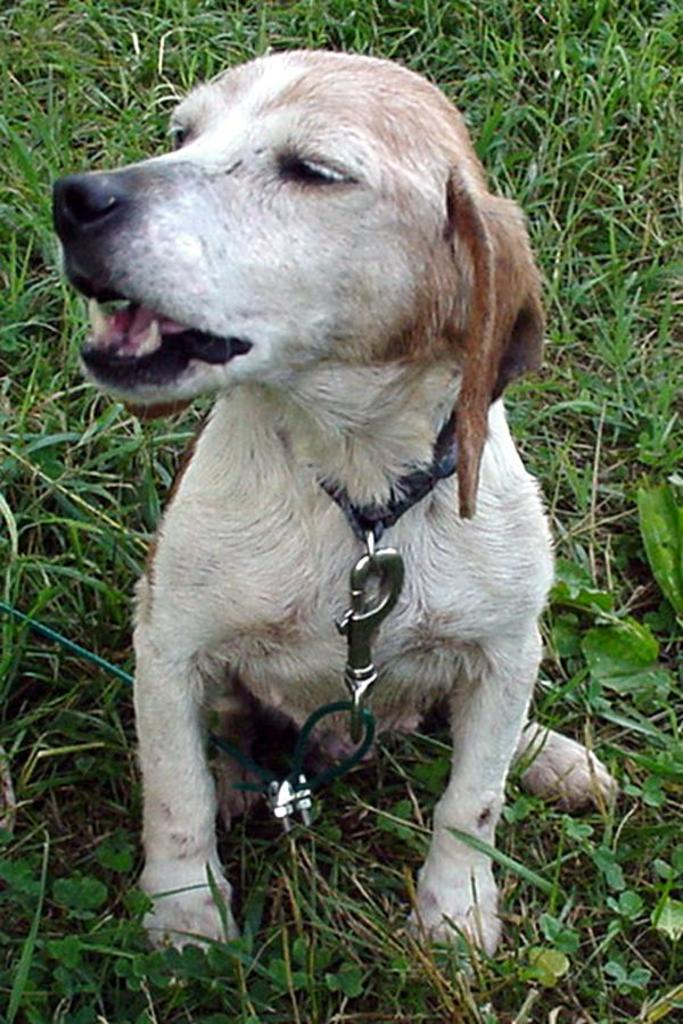What animal can be seen in the image? There is a dog in the image. Where is the dog located in the image? The dog is sitting on the grass. What type of location is the image taken in? The image is taken in a park. At what time of day was the image taken? The image is taken during the day. What type of lumber is the dog using to build a treehouse in the image? There is no lumber or treehouse present in the image; it features a dog sitting on the grass in a park. How many hands does the dog have in the image? Dogs do not have hands; they have paws. 